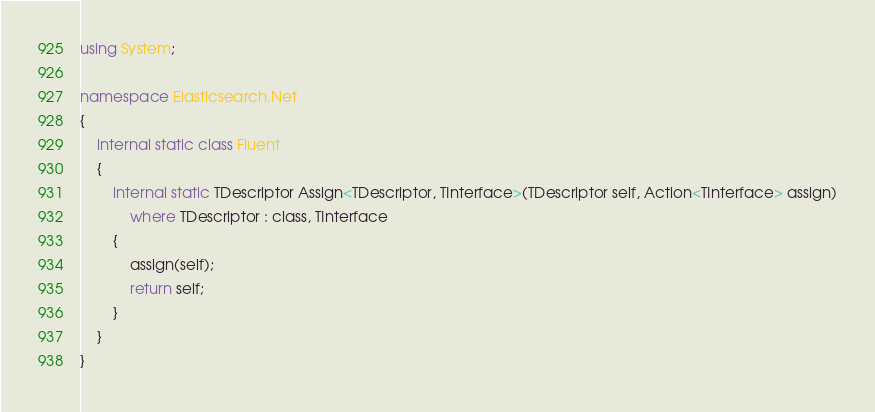Convert code to text. <code><loc_0><loc_0><loc_500><loc_500><_C#_>using System;

namespace Elasticsearch.Net
{
	internal static class Fluent
	{
		internal static TDescriptor Assign<TDescriptor, TInterface>(TDescriptor self, Action<TInterface> assign)
			where TDescriptor : class, TInterface
		{
			assign(self);
			return self;
		}
	}
}
</code> 